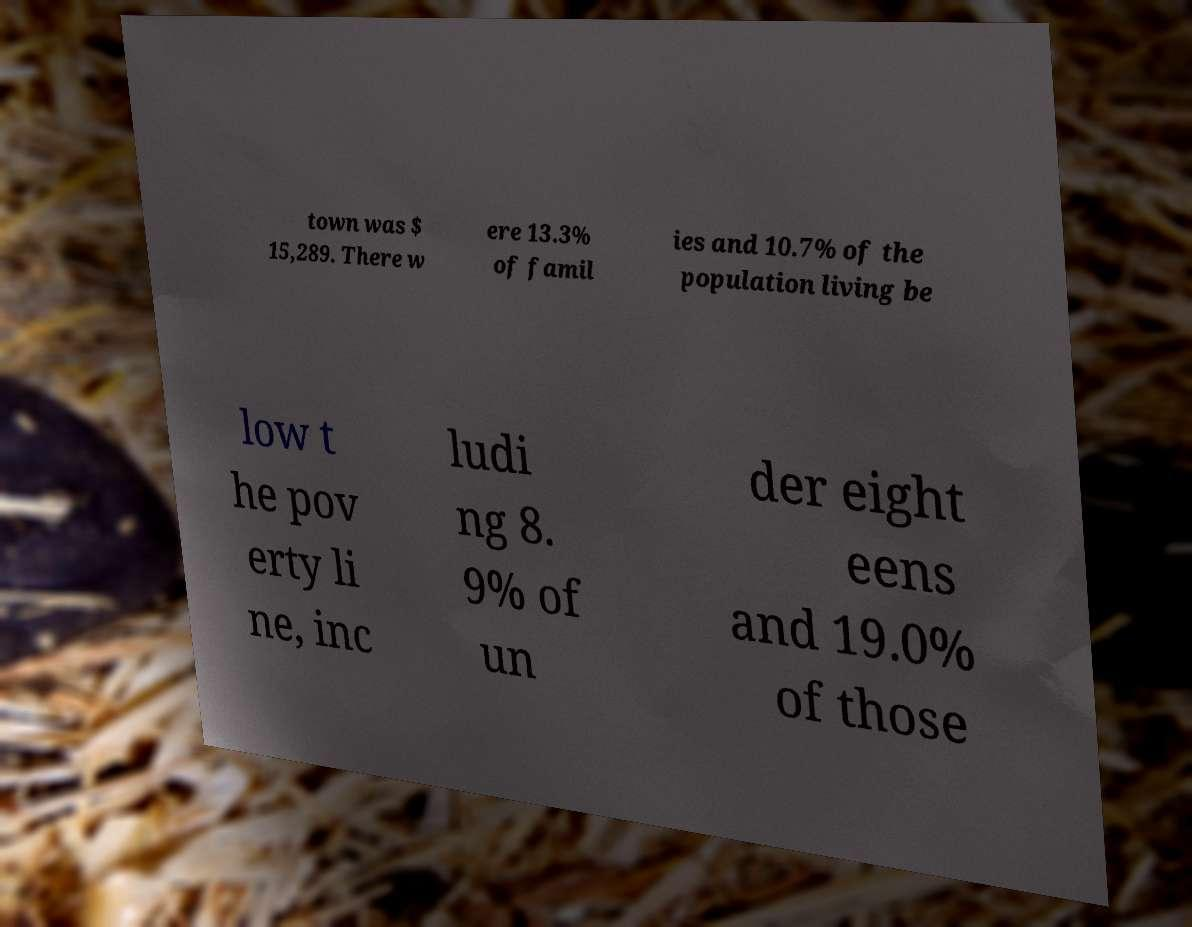Could you assist in decoding the text presented in this image and type it out clearly? town was $ 15,289. There w ere 13.3% of famil ies and 10.7% of the population living be low t he pov erty li ne, inc ludi ng 8. 9% of un der eight eens and 19.0% of those 